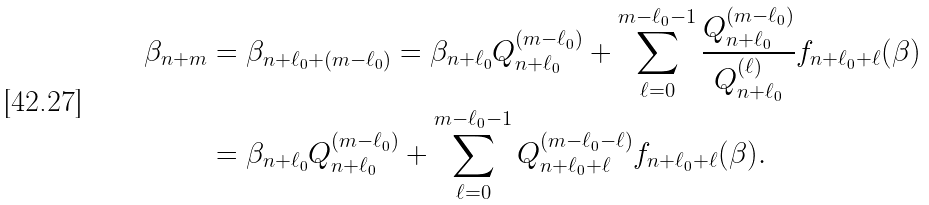Convert formula to latex. <formula><loc_0><loc_0><loc_500><loc_500>\beta _ { n + m } & = \beta _ { n + \ell _ { 0 } + ( m - \ell _ { 0 } ) } = \beta _ { n + \ell _ { 0 } } Q _ { n + \ell _ { 0 } } ^ { ( m - \ell _ { 0 } ) } + \sum _ { \ell = 0 } ^ { m - \ell _ { 0 } - 1 } \frac { Q _ { n + \ell _ { 0 } } ^ { ( m - \ell _ { 0 } ) } } { Q _ { n + \ell _ { 0 } } ^ { ( \ell ) } } f _ { n + \ell _ { 0 } + \ell } ( \beta ) \\ & = \beta _ { n + \ell _ { 0 } } Q _ { n + \ell _ { 0 } } ^ { ( m - \ell _ { 0 } ) } + \sum _ { \ell = 0 } ^ { m - \ell _ { 0 } - 1 } Q _ { n + \ell _ { 0 } + \ell } ^ { ( m - \ell _ { 0 } - \ell ) } f _ { n + \ell _ { 0 } + \ell } ( \beta ) .</formula> 